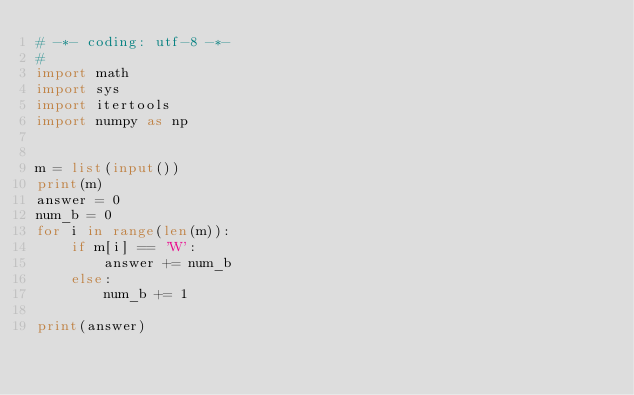<code> <loc_0><loc_0><loc_500><loc_500><_Python_># -*- coding: utf-8 -*-
# 
import math
import sys
import itertools
import numpy as np


m = list(input())
print(m)
answer = 0
num_b = 0
for i in range(len(m)):
    if m[i] == 'W':
        answer += num_b
    else:
        num_b += 1

print(answer)
</code> 